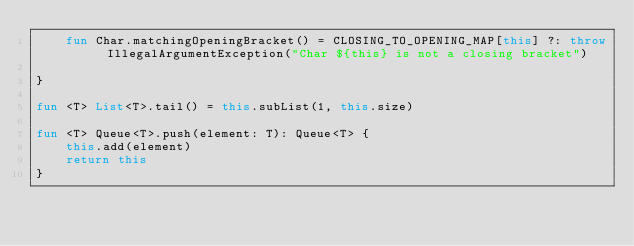Convert code to text. <code><loc_0><loc_0><loc_500><loc_500><_Kotlin_>    fun Char.matchingOpeningBracket() = CLOSING_TO_OPENING_MAP[this] ?: throw IllegalArgumentException("Char ${this} is not a closing bracket")

}

fun <T> List<T>.tail() = this.subList(1, this.size)

fun <T> Queue<T>.push(element: T): Queue<T> {
    this.add(element)
    return this
}
</code> 